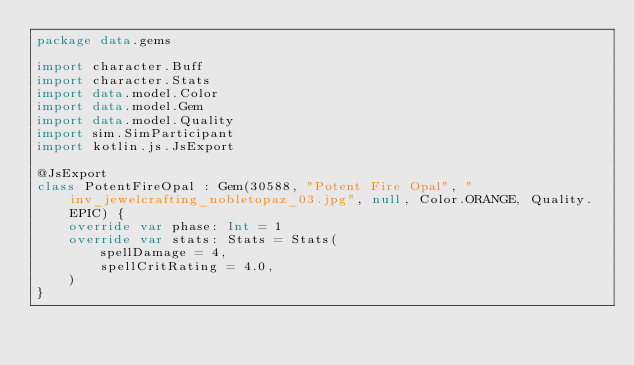Convert code to text. <code><loc_0><loc_0><loc_500><loc_500><_Kotlin_>package data.gems

import character.Buff
import character.Stats
import data.model.Color
import data.model.Gem
import data.model.Quality
import sim.SimParticipant
import kotlin.js.JsExport

@JsExport
class PotentFireOpal : Gem(30588, "Potent Fire Opal", "inv_jewelcrafting_nobletopaz_03.jpg", null, Color.ORANGE, Quality.EPIC) {
    override var phase: Int = 1
    override var stats: Stats = Stats(
        spellDamage = 4,
        spellCritRating = 4.0,
    )
}
</code> 